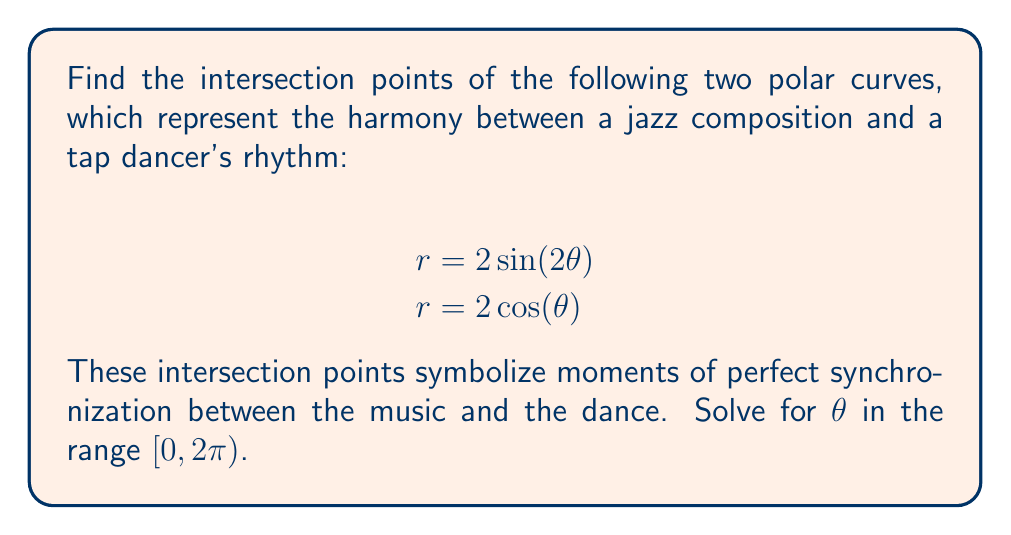Teach me how to tackle this problem. To find the intersection points, we need to equate the two equations:

$$2\sin(2\theta) = 2\cos(\theta)$$

Simplifying:

$$\sin(2\theta) = \cos(\theta)$$

Using the double angle formula for sine:

$$2\sin(\theta)\cos(\theta) = \cos(\theta)$$

Dividing both sides by $\cos(\theta)$ (assuming $\cos(\theta) \neq 0$):

$$2\sin(\theta) = 1$$

$$\sin(\theta) = \frac{1}{2}$$

Solving for $\theta$ in the range $[0, 2\pi)$:

$$\theta_1 = \arcsin(\frac{1}{2}) = \frac{\pi}{6}$$
$$\theta_2 = \pi - \frac{\pi}{6} = \frac{5\pi}{6}$$

We need to check these solutions in the original equations to ensure they satisfy both:

For $\theta_1 = \frac{\pi}{6}$:
$$r = 2\sin(2\cdot\frac{\pi}{6}) = 2\sin(\frac{\pi}{3}) = \sqrt{3}$$
$$r = 2\cos(\frac{\pi}{6}) = \sqrt{3}$$

For $\theta_2 = \frac{5\pi}{6}$:
$$r = 2\sin(2\cdot\frac{5\pi}{6}) = 2\sin(\frac{5\pi}{3}) = -\sqrt{3}$$
$$r = 2\cos(\frac{5\pi}{6}) = -\sqrt{3}$$

Both solutions satisfy the equations. To find the Cartesian coordinates, we use:
$$x = r\cos(\theta), y = r\sin(\theta)$$

For $\theta_1 = \frac{\pi}{6}$:
$$x = \sqrt{3}\cos(\frac{\pi}{6}) = \frac{3}{2}, y = \sqrt{3}\sin(\frac{\pi}{6}) = \frac{\sqrt{3}}{2}$$

For $\theta_2 = \frac{5\pi}{6}$:
$$x = -\sqrt{3}\cos(\frac{5\pi}{6}) = -\frac{3}{2}, y = -\sqrt{3}\sin(\frac{5\pi}{6}) = -\frac{\sqrt{3}}{2}$$
Answer: The intersection points are:
$$(\frac{\pi}{6}, \sqrt{3}) \text{ and } (\frac{5\pi}{6}, -\sqrt{3}) \text{ in polar coordinates}$$
$$(\frac{3}{2}, \frac{\sqrt{3}}{2}) \text{ and } (-\frac{3}{2}, -\frac{\sqrt{3}}{2}) \text{ in Cartesian coordinates}$$ 